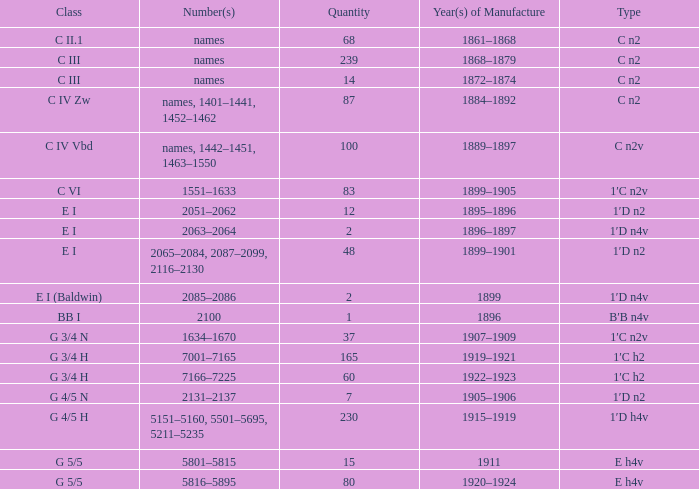What item has an e h4v classification and was manufactured between 1920-1924? 80.0. 